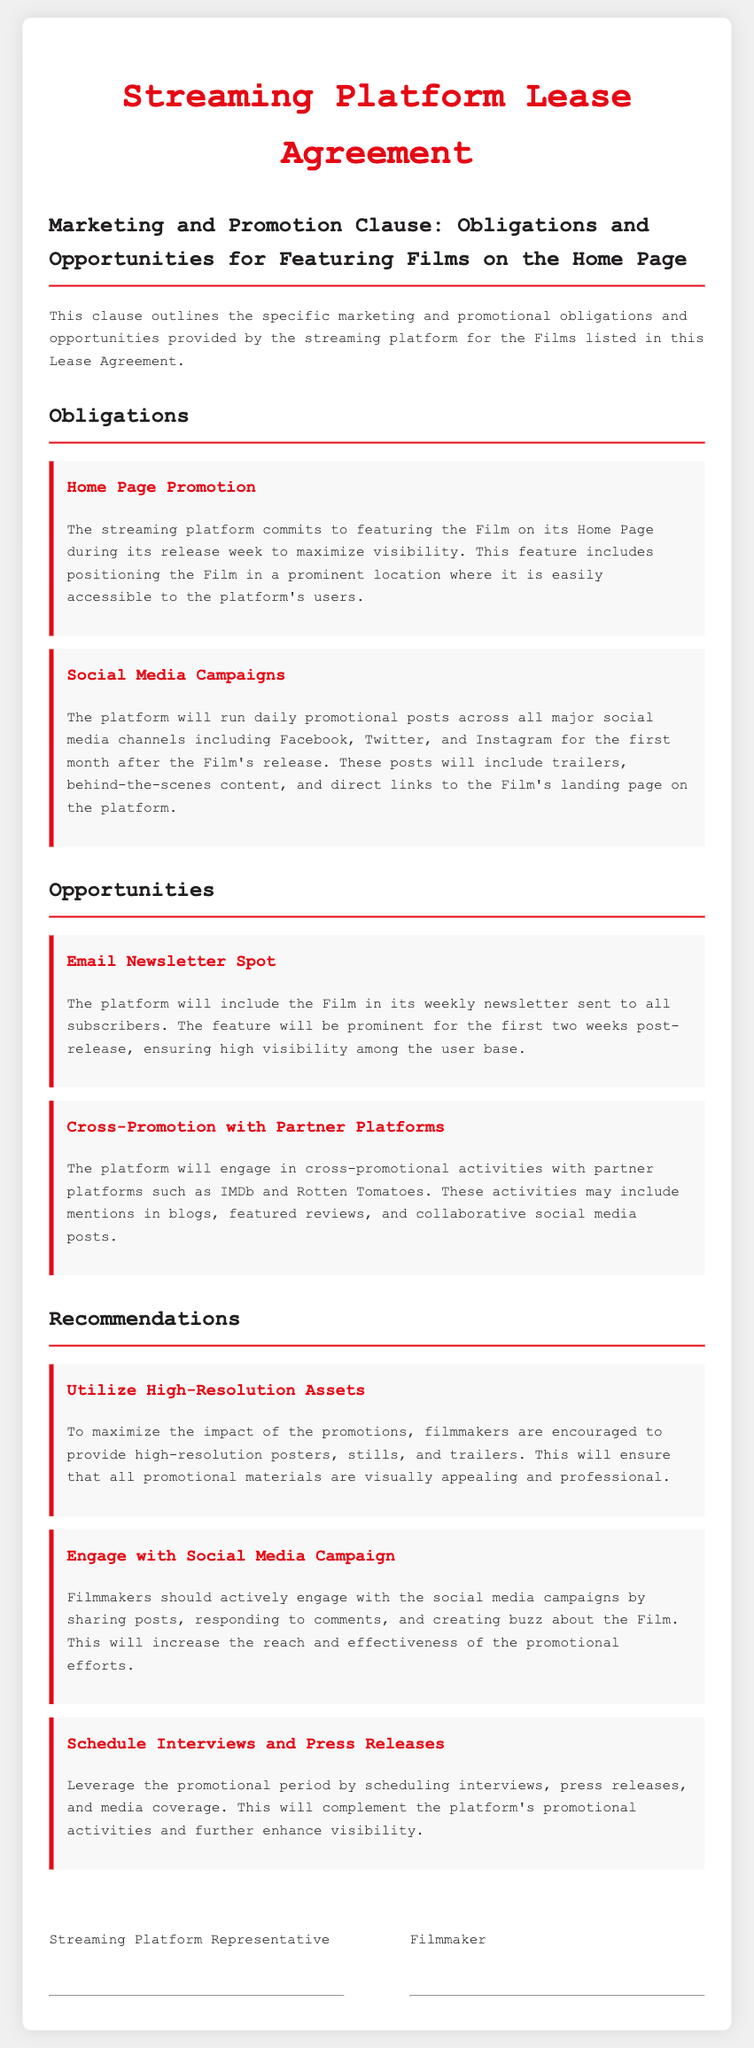What is the commitment of the streaming platform during the release week? The streaming platform commits to featuring the Film on its Home Page during its release week to maximize visibility.
Answer: Home Page How long will social media campaigns run after the Film's release? The platform will run daily promotional posts across all major social media channels for the first month after the Film's release.
Answer: One month How long will the Film be featured in the weekly newsletter? The feature will be prominent for the first two weeks post-release, ensuring high visibility among the user base.
Answer: Two weeks What type of assets are filmmakers encouraged to provide? To maximize the impact of the promotions, filmmakers are encouraged to provide high-resolution posters, stills, and trailers.
Answer: High-resolution assets What is one way filmmakers can engage with the social media campaign? Filmmakers should actively engage with the social media campaigns by sharing posts, responding to comments, and creating buzz about the Film.
Answer: Sharing posts What promotional activity involves cross-promotion with partner platforms? The platform will engage in cross-promotional activities with partner platforms such as IMDb and Rotten Tomatoes.
Answer: Cross-Promotion What kind of content will the daily posts include? These posts will include trailers, behind-the-scenes content, and direct links to the Film's landing page on the platform.
Answer: Trailers, behind-the-scenes content What must filmmakers schedule to complement the platform's promotional activities? Leverage the promotional period by scheduling interviews, press releases, and media coverage.
Answer: Interviews and press releases 